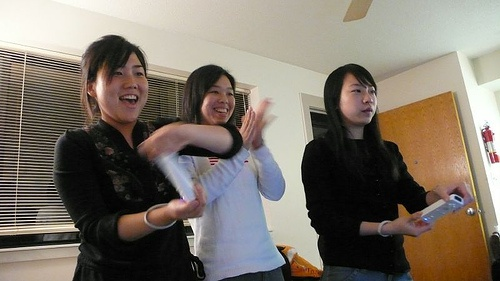Describe the objects in this image and their specific colors. I can see people in ivory, black, gray, and maroon tones, people in ivory, black, gray, and maroon tones, people in ivory, darkgray, gray, and black tones, remote in ivory, darkgray, gray, and black tones, and remote in ivory, gray, and darkgray tones in this image. 